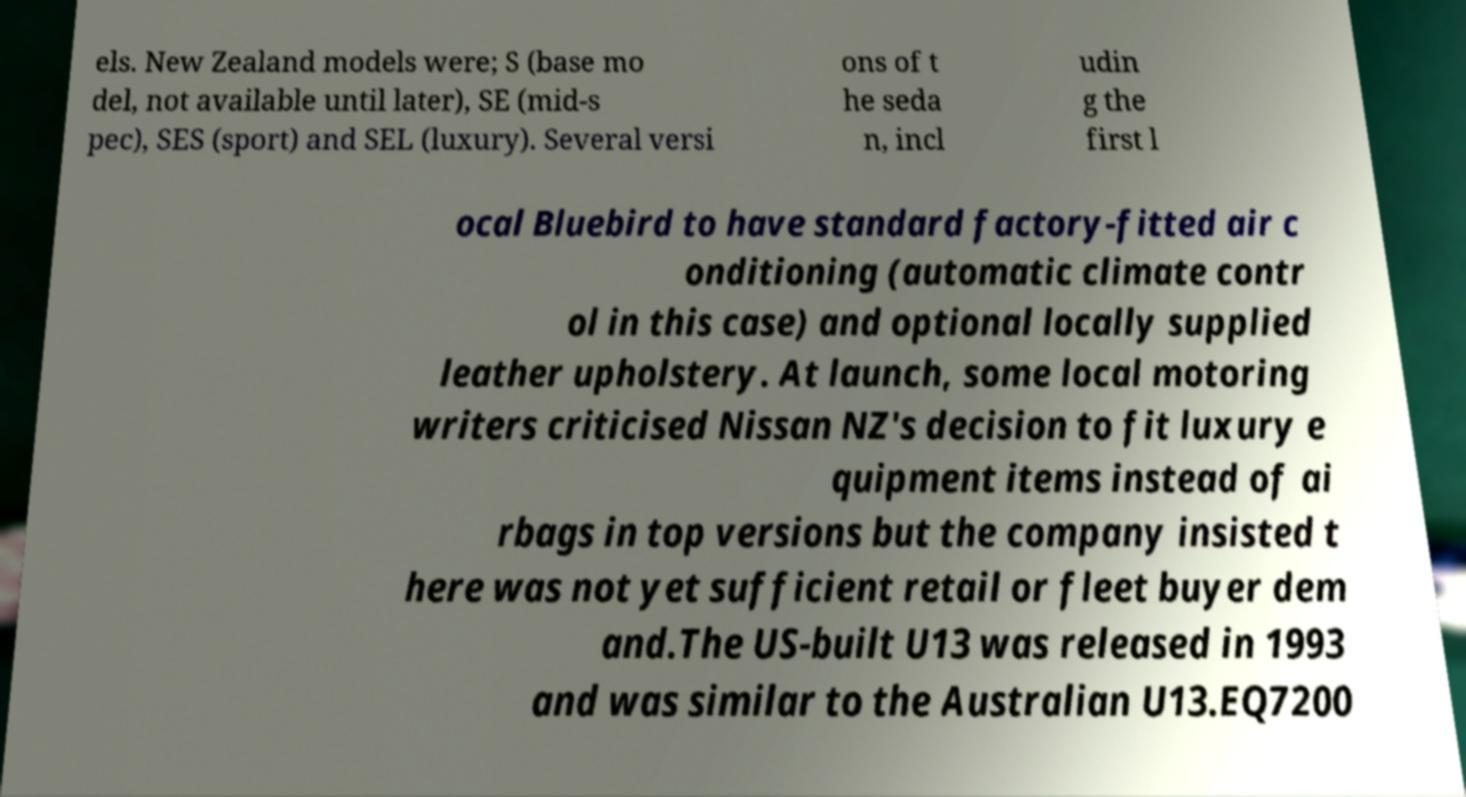For documentation purposes, I need the text within this image transcribed. Could you provide that? els. New Zealand models were; S (base mo del, not available until later), SE (mid-s pec), SES (sport) and SEL (luxury). Several versi ons of t he seda n, incl udin g the first l ocal Bluebird to have standard factory-fitted air c onditioning (automatic climate contr ol in this case) and optional locally supplied leather upholstery. At launch, some local motoring writers criticised Nissan NZ's decision to fit luxury e quipment items instead of ai rbags in top versions but the company insisted t here was not yet sufficient retail or fleet buyer dem and.The US-built U13 was released in 1993 and was similar to the Australian U13.EQ7200 